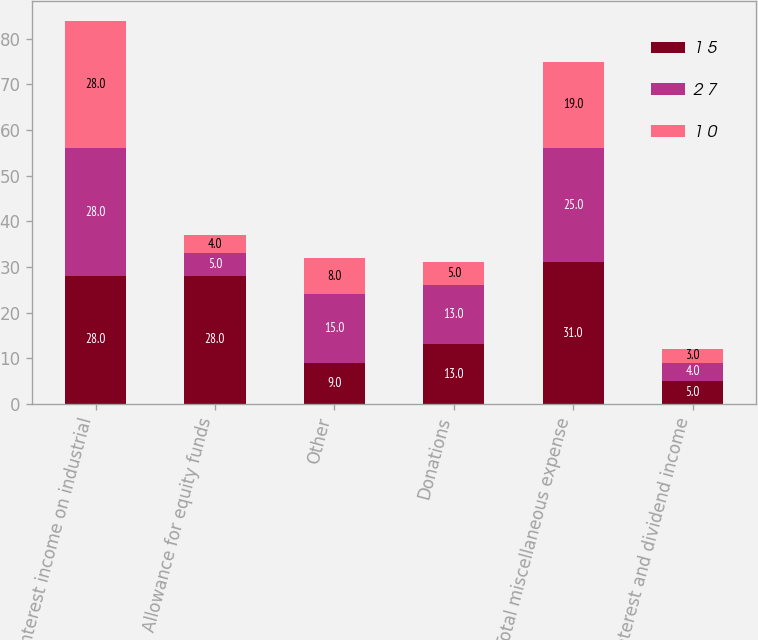Convert chart to OTSL. <chart><loc_0><loc_0><loc_500><loc_500><stacked_bar_chart><ecel><fcel>Interest income on industrial<fcel>Allowance for equity funds<fcel>Other<fcel>Donations<fcel>Total miscellaneous expense<fcel>Interest and dividend income<nl><fcel>1 5<fcel>28<fcel>28<fcel>9<fcel>13<fcel>31<fcel>5<nl><fcel>2 7<fcel>28<fcel>5<fcel>15<fcel>13<fcel>25<fcel>4<nl><fcel>1 0<fcel>28<fcel>4<fcel>8<fcel>5<fcel>19<fcel>3<nl></chart> 